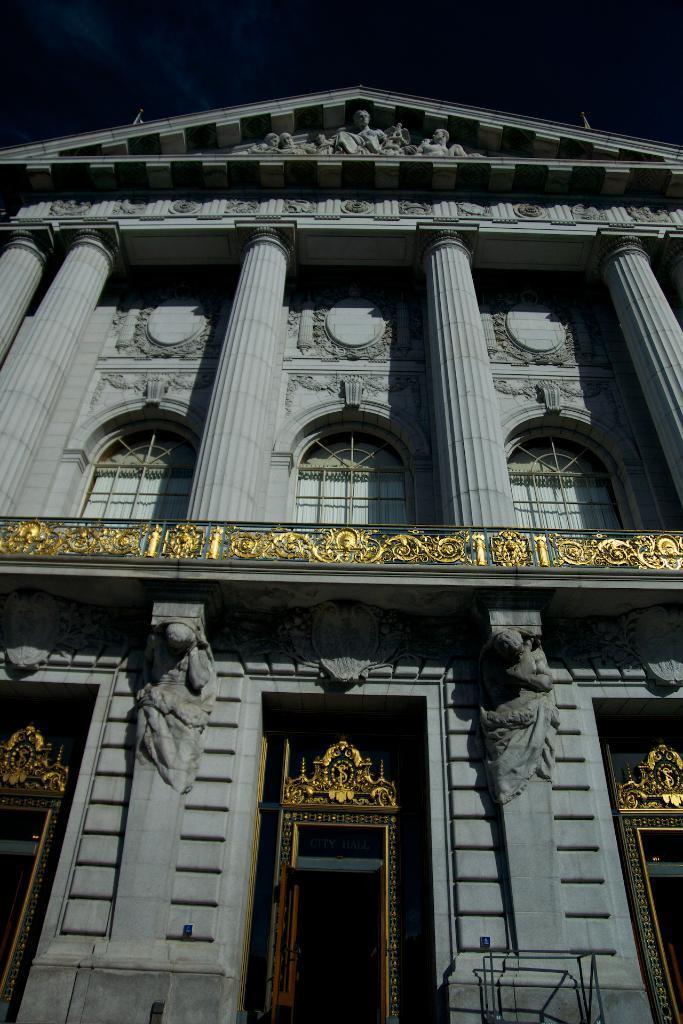How would you summarize this image in a sentence or two? In this image there is a building truncated, there are pillars, there is a pillar truncated towards the right of the image, there are pillars truncated towards the left of the image, there are sculptures on the building, there is an object truncated towards the bottom of the image. 